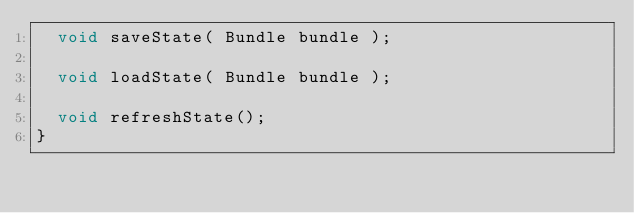Convert code to text. <code><loc_0><loc_0><loc_500><loc_500><_Java_>	void saveState( Bundle bundle );

	void loadState( Bundle bundle );

	void refreshState();
}
</code> 